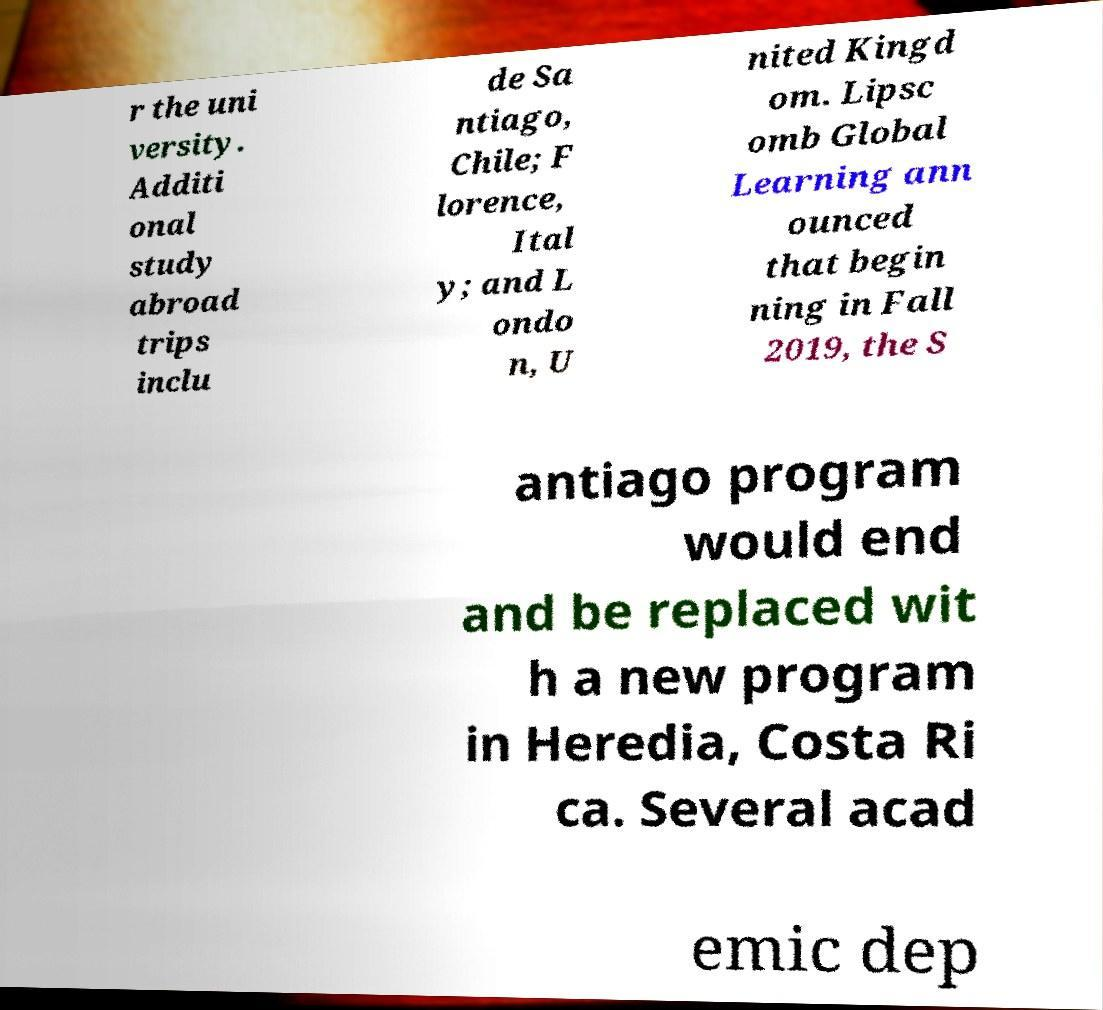Can you accurately transcribe the text from the provided image for me? r the uni versity. Additi onal study abroad trips inclu de Sa ntiago, Chile; F lorence, Ital y; and L ondo n, U nited Kingd om. Lipsc omb Global Learning ann ounced that begin ning in Fall 2019, the S antiago program would end and be replaced wit h a new program in Heredia, Costa Ri ca. Several acad emic dep 